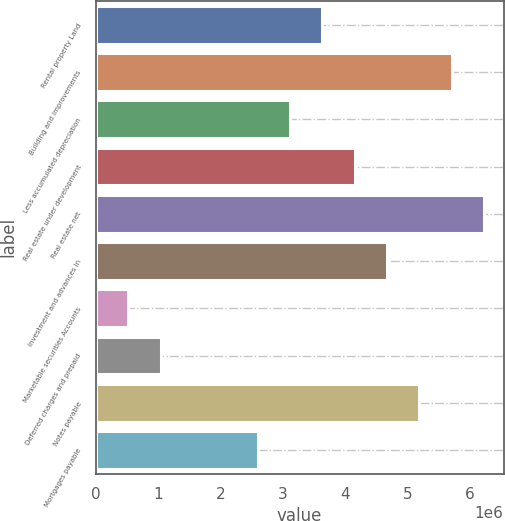Convert chart to OTSL. <chart><loc_0><loc_0><loc_500><loc_500><bar_chart><fcel>Rental property Land<fcel>Building and improvements<fcel>Less accumulated depreciation<fcel>Real estate under development<fcel>Real estate net<fcel>Investment and advances in<fcel>Marketable securities Accounts<fcel>Deferred charges and prepaid<fcel>Notes payable<fcel>Mortgages payable<nl><fcel>3.63646e+06<fcel>5.71404e+06<fcel>3.11707e+06<fcel>4.15586e+06<fcel>6.23344e+06<fcel>4.67525e+06<fcel>520095<fcel>1.03949e+06<fcel>5.19465e+06<fcel>2.59767e+06<nl></chart> 